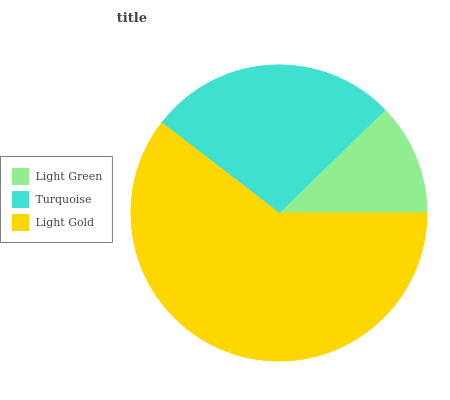Is Light Green the minimum?
Answer yes or no. Yes. Is Light Gold the maximum?
Answer yes or no. Yes. Is Turquoise the minimum?
Answer yes or no. No. Is Turquoise the maximum?
Answer yes or no. No. Is Turquoise greater than Light Green?
Answer yes or no. Yes. Is Light Green less than Turquoise?
Answer yes or no. Yes. Is Light Green greater than Turquoise?
Answer yes or no. No. Is Turquoise less than Light Green?
Answer yes or no. No. Is Turquoise the high median?
Answer yes or no. Yes. Is Turquoise the low median?
Answer yes or no. Yes. Is Light Green the high median?
Answer yes or no. No. Is Light Gold the low median?
Answer yes or no. No. 